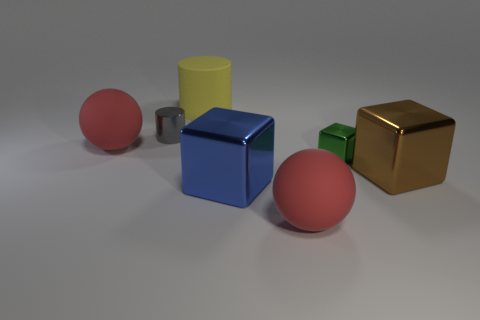Add 3 blue spheres. How many objects exist? 10 Subtract all big shiny blocks. How many blocks are left? 1 Subtract all gray cylinders. How many cylinders are left? 1 Add 2 large gray matte balls. How many large gray matte balls exist? 2 Subtract 1 brown cubes. How many objects are left? 6 Subtract all blocks. How many objects are left? 4 Subtract all green cylinders. Subtract all purple spheres. How many cylinders are left? 2 Subtract all brown cubes. How many gray cylinders are left? 1 Subtract all cylinders. Subtract all tiny gray things. How many objects are left? 4 Add 5 brown shiny objects. How many brown shiny objects are left? 6 